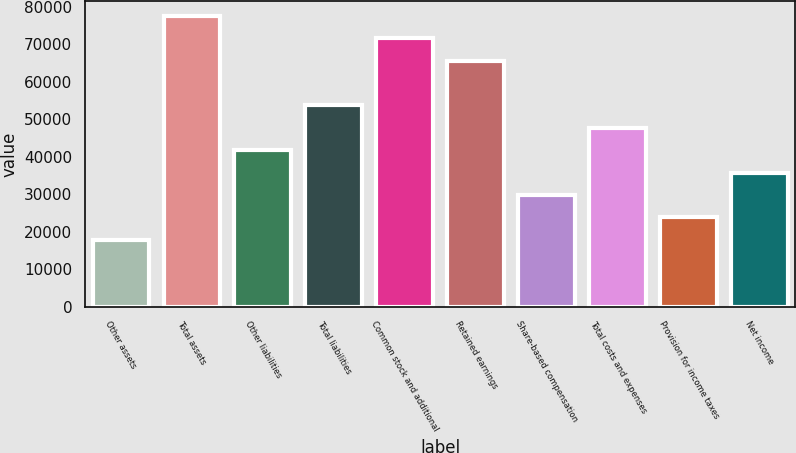<chart> <loc_0><loc_0><loc_500><loc_500><bar_chart><fcel>Other assets<fcel>Total assets<fcel>Other liabilities<fcel>Total liabilities<fcel>Common stock and additional<fcel>Retained earnings<fcel>Share-based compensation<fcel>Total costs and expenses<fcel>Provision for income taxes<fcel>Net income<nl><fcel>17902.8<fcel>77576<fcel>41772.1<fcel>53706.7<fcel>71608.7<fcel>65641.3<fcel>29837.4<fcel>47739.4<fcel>23870.1<fcel>35804.7<nl></chart> 